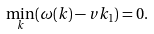Convert formula to latex. <formula><loc_0><loc_0><loc_500><loc_500>\min _ { k } ( \omega ( { k } ) - v k _ { 1 } ) = 0 .</formula> 